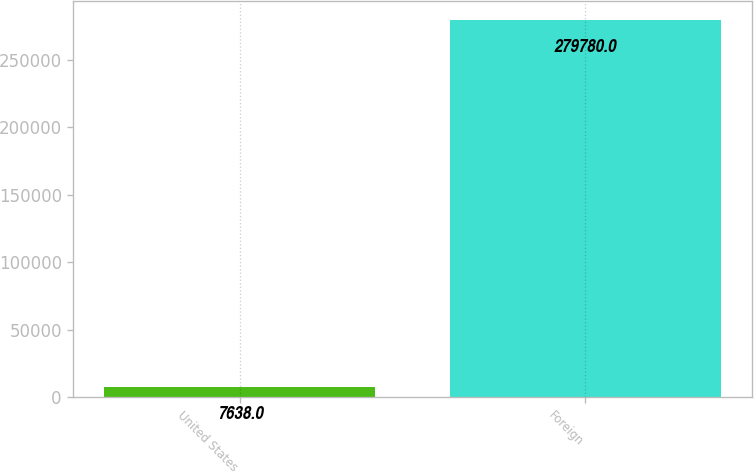<chart> <loc_0><loc_0><loc_500><loc_500><bar_chart><fcel>United States<fcel>Foreign<nl><fcel>7638<fcel>279780<nl></chart> 